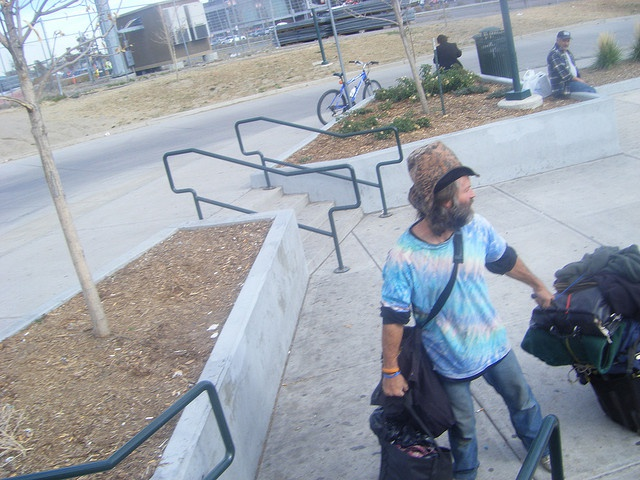Describe the objects in this image and their specific colors. I can see people in darkgray, gray, and lightblue tones, handbag in darkgray, black, darkblue, and gray tones, handbag in darkgray, black, gray, navy, and darkblue tones, handbag in darkgray, black, purple, and darkblue tones, and suitcase in darkgray, black, and gray tones in this image. 